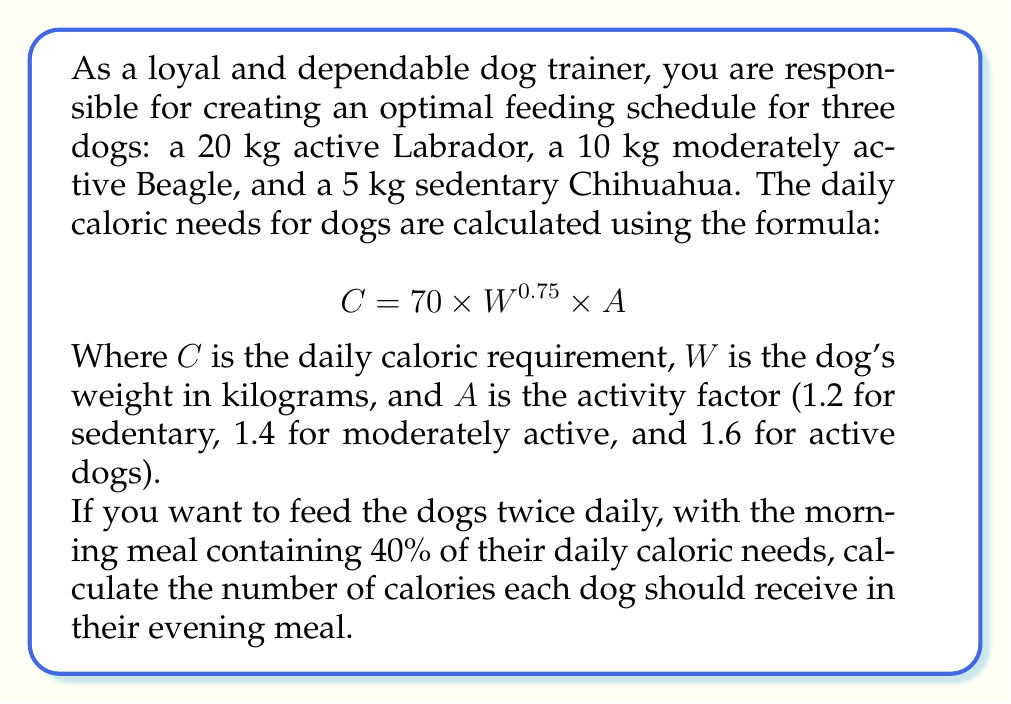Give your solution to this math problem. Let's solve this problem step by step:

1. Calculate the daily caloric needs for each dog:

   a) Labrador (20 kg, active):
      $C_{Lab} = 70 \times 20^{0.75} \times 1.6 = 70 \times 9.46 \times 1.6 = 1,059.52$ calories

   b) Beagle (10 kg, moderately active):
      $C_{Beagle} = 70 \times 10^{0.75} \times 1.4 = 70 \times 5.62 \times 1.4 = 550.76$ calories

   c) Chihuahua (5 kg, sedentary):
      $C_{Chi} = 70 \times 5^{0.75} \times 1.2 = 70 \times 3.34 \times 1.2 = 280.56$ calories

2. Calculate the evening meal calories (60% of daily needs):

   a) Labrador:
      $E_{Lab} = 0.6 \times 1,059.52 = 635.71$ calories

   b) Beagle:
      $E_{Beagle} = 0.6 \times 550.76 = 330.46$ calories

   c) Chihuahua:
      $E_{Chi} = 0.6 \times 280.56 = 168.34$ calories

Therefore, the evening meal for each dog should contain the calculated number of calories.
Answer: The evening meal should contain:
Labrador: 636 calories
Beagle: 330 calories
Chihuahua: 168 calories 